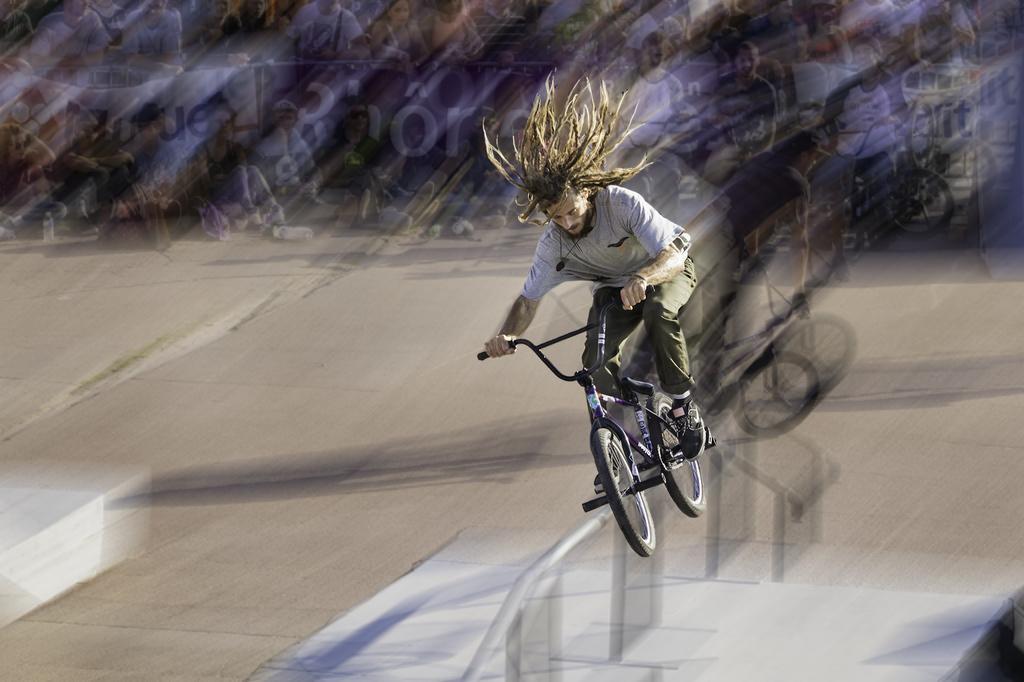Describe this image in one or two sentences. There is a person is jumping with bicycle. It is a blur image. Top of the image, we can see few people and bicycles. 